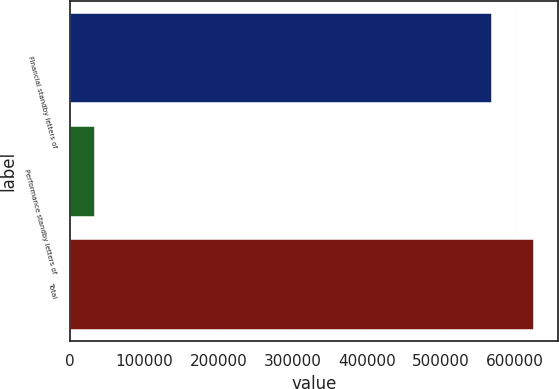Convert chart. <chart><loc_0><loc_0><loc_500><loc_500><bar_chart><fcel>Financial standby letters of<fcel>Performance standby letters of<fcel>Total<nl><fcel>568797<fcel>32970<fcel>626099<nl></chart> 